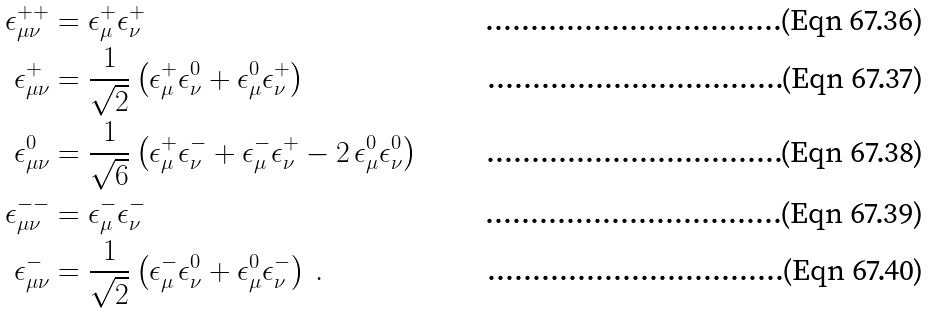<formula> <loc_0><loc_0><loc_500><loc_500>\epsilon _ { \mu \nu } ^ { + + } & = \epsilon _ { \mu } ^ { + } \epsilon _ { \nu } ^ { + } \\ \epsilon _ { \mu \nu } ^ { + } & = \frac { 1 } { \sqrt { 2 } } \left ( \epsilon _ { \mu } ^ { + } \epsilon _ { \nu } ^ { 0 } + \epsilon _ { \mu } ^ { 0 } \epsilon _ { \nu } ^ { + } \right ) \\ \epsilon _ { \mu \nu } ^ { 0 } & = \frac { 1 } { \sqrt { 6 } } \left ( \epsilon _ { \mu } ^ { + } \epsilon _ { \nu } ^ { - } + \epsilon _ { \mu } ^ { - } \epsilon _ { \nu } ^ { + } - 2 \, \epsilon _ { \mu } ^ { 0 } \epsilon _ { \nu } ^ { 0 } \right ) \\ \epsilon _ { \mu \nu } ^ { - - } & = \epsilon _ { \mu } ^ { - } \epsilon _ { \nu } ^ { - } \\ \epsilon _ { \mu \nu } ^ { - } & = \frac { 1 } { \sqrt { 2 } } \left ( \epsilon _ { \mu } ^ { - } \epsilon _ { \nu } ^ { 0 } + \epsilon _ { \mu } ^ { 0 } \epsilon _ { \nu } ^ { - } \right ) \, .</formula> 